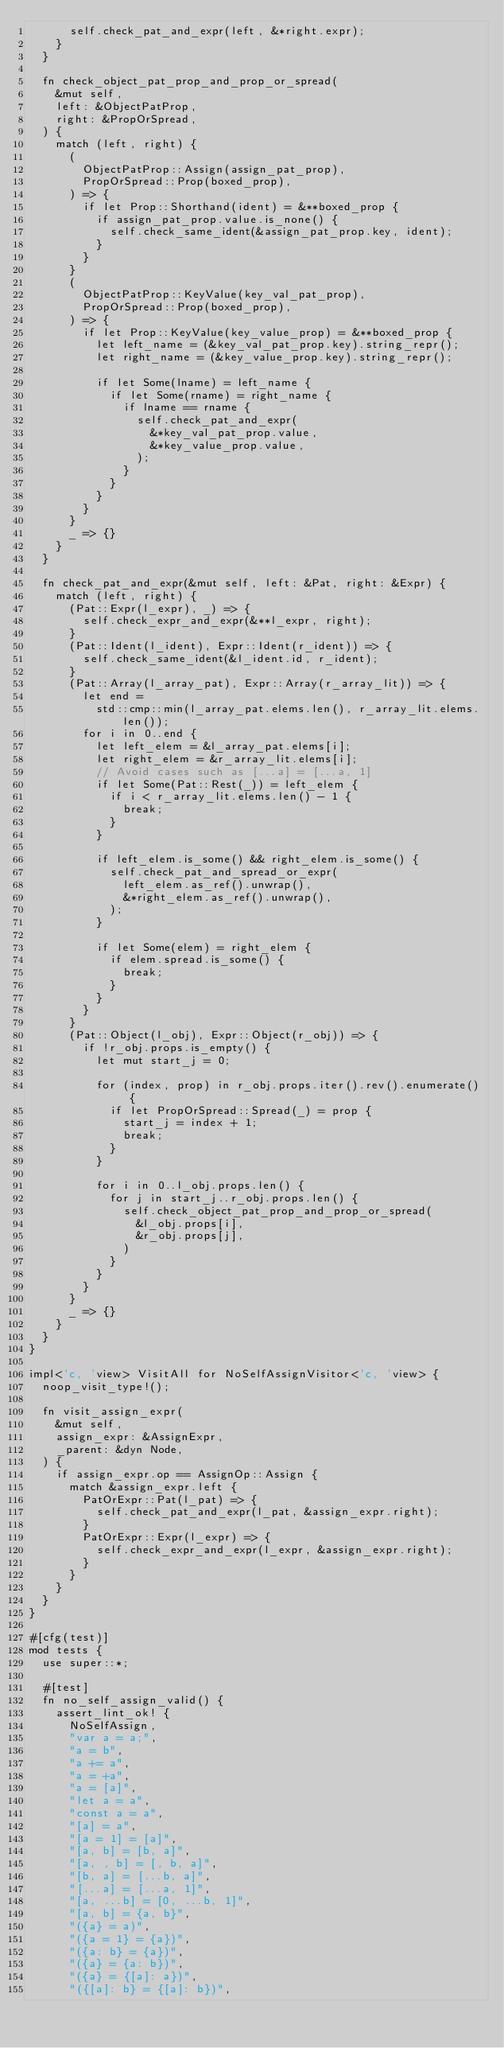<code> <loc_0><loc_0><loc_500><loc_500><_Rust_>      self.check_pat_and_expr(left, &*right.expr);
    }
  }

  fn check_object_pat_prop_and_prop_or_spread(
    &mut self,
    left: &ObjectPatProp,
    right: &PropOrSpread,
  ) {
    match (left, right) {
      (
        ObjectPatProp::Assign(assign_pat_prop),
        PropOrSpread::Prop(boxed_prop),
      ) => {
        if let Prop::Shorthand(ident) = &**boxed_prop {
          if assign_pat_prop.value.is_none() {
            self.check_same_ident(&assign_pat_prop.key, ident);
          }
        }
      }
      (
        ObjectPatProp::KeyValue(key_val_pat_prop),
        PropOrSpread::Prop(boxed_prop),
      ) => {
        if let Prop::KeyValue(key_value_prop) = &**boxed_prop {
          let left_name = (&key_val_pat_prop.key).string_repr();
          let right_name = (&key_value_prop.key).string_repr();

          if let Some(lname) = left_name {
            if let Some(rname) = right_name {
              if lname == rname {
                self.check_pat_and_expr(
                  &*key_val_pat_prop.value,
                  &*key_value_prop.value,
                );
              }
            }
          }
        }
      }
      _ => {}
    }
  }

  fn check_pat_and_expr(&mut self, left: &Pat, right: &Expr) {
    match (left, right) {
      (Pat::Expr(l_expr), _) => {
        self.check_expr_and_expr(&**l_expr, right);
      }
      (Pat::Ident(l_ident), Expr::Ident(r_ident)) => {
        self.check_same_ident(&l_ident.id, r_ident);
      }
      (Pat::Array(l_array_pat), Expr::Array(r_array_lit)) => {
        let end =
          std::cmp::min(l_array_pat.elems.len(), r_array_lit.elems.len());
        for i in 0..end {
          let left_elem = &l_array_pat.elems[i];
          let right_elem = &r_array_lit.elems[i];
          // Avoid cases such as [...a] = [...a, 1]
          if let Some(Pat::Rest(_)) = left_elem {
            if i < r_array_lit.elems.len() - 1 {
              break;
            }
          }

          if left_elem.is_some() && right_elem.is_some() {
            self.check_pat_and_spread_or_expr(
              left_elem.as_ref().unwrap(),
              &*right_elem.as_ref().unwrap(),
            );
          }

          if let Some(elem) = right_elem {
            if elem.spread.is_some() {
              break;
            }
          }
        }
      }
      (Pat::Object(l_obj), Expr::Object(r_obj)) => {
        if !r_obj.props.is_empty() {
          let mut start_j = 0;

          for (index, prop) in r_obj.props.iter().rev().enumerate() {
            if let PropOrSpread::Spread(_) = prop {
              start_j = index + 1;
              break;
            }
          }

          for i in 0..l_obj.props.len() {
            for j in start_j..r_obj.props.len() {
              self.check_object_pat_prop_and_prop_or_spread(
                &l_obj.props[i],
                &r_obj.props[j],
              )
            }
          }
        }
      }
      _ => {}
    }
  }
}

impl<'c, 'view> VisitAll for NoSelfAssignVisitor<'c, 'view> {
  noop_visit_type!();

  fn visit_assign_expr(
    &mut self,
    assign_expr: &AssignExpr,
    _parent: &dyn Node,
  ) {
    if assign_expr.op == AssignOp::Assign {
      match &assign_expr.left {
        PatOrExpr::Pat(l_pat) => {
          self.check_pat_and_expr(l_pat, &assign_expr.right);
        }
        PatOrExpr::Expr(l_expr) => {
          self.check_expr_and_expr(l_expr, &assign_expr.right);
        }
      }
    }
  }
}

#[cfg(test)]
mod tests {
  use super::*;

  #[test]
  fn no_self_assign_valid() {
    assert_lint_ok! {
      NoSelfAssign,
      "var a = a;",
      "a = b",
      "a += a",
      "a = +a",
      "a = [a]",
      "let a = a",
      "const a = a",
      "[a] = a",
      "[a = 1] = [a]",
      "[a, b] = [b, a]",
      "[a, , b] = [, b, a]",
      "[b, a] = [...b, a]",
      "[...a] = [...a, 1]",
      "[a, ...b] = [0, ...b, 1]",
      "[a, b] = {a, b}",
      "({a} = a)",
      "({a = 1} = {a})",
      "({a: b} = {a})",
      "({a} = {a: b})",
      "({a} = {[a]: a})",
      "({[a]: b} = {[a]: b})",</code> 